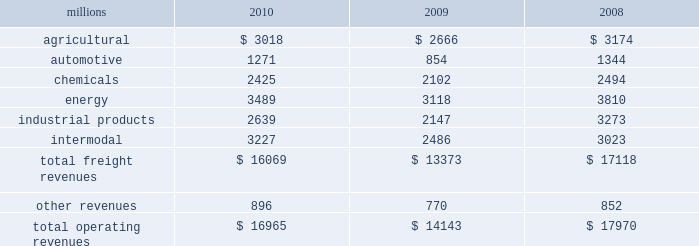Notes to the consolidated financial statements union pacific corporation and subsidiary companies for purposes of this report , unless the context otherwise requires , all references herein to the 201ccorporation 201d , 201cupc 201d , 201cwe 201d , 201cus 201d , and 201cour 201d mean union pacific corporation and its subsidiaries , including union pacific railroad company , which will be separately referred to herein as 201cuprr 201d or the 201crailroad 201d .
Nature of operations operations and segmentation 2013 we are a class i railroad that operates in the u.s .
We have 31953 route miles , linking pacific coast and gulf coast ports with the midwest and eastern u.s .
Gateways and providing several corridors to key mexican gateways .
We serve the western two-thirds of the country and maintain coordinated schedules with other rail carriers for the handling of freight to and from the atlantic coast , the pacific coast , the southeast , the southwest , canada , and mexico .
Export and import traffic is moved through gulf coast and pacific coast ports and across the mexican and canadian borders .
The railroad , along with its subsidiaries and rail affiliates , is our one reportable operating segment .
Although revenues are analyzed by commodity group , we analyze the net financial results of the railroad as one segment due to the integrated nature of our rail network .
The table provides revenue by commodity group : millions 2010 2009 2008 .
Although our revenues are principally derived from customers domiciled in the u.s. , the ultimate points of origination or destination for some products transported are outside the u.s .
Basis of presentation 2013 the consolidated financial statements are presented in accordance with accounting principles generally accepted in the u.s .
( gaap ) as codified in the financial accounting standards board ( fasb ) accounting standards codification ( asc ) .
Significant accounting policies principles of consolidation 2013 the consolidated financial statements include the accounts of union pacific corporation and all of its subsidiaries .
Investments in affiliated companies ( 20% ( 20 % ) to 50% ( 50 % ) owned ) are accounted for using the equity method of accounting .
All intercompany transactions are eliminated .
We currently have no less than majority-owned investments that require consolidation under variable interest entity requirements .
Cash and cash equivalents 2013 cash equivalents consist of investments with original maturities of three months or less .
Accounts receivable 2013 accounts receivable includes receivables reduced by an allowance for doubtful accounts .
The allowance is based upon historical losses , credit worthiness of customers , and current economic conditions .
Receivables not expected to be collected in one year and the associated allowances are classified as other assets in our consolidated statements of financial position .
Investments 2013 investments represent our investments in affiliated companies ( 20% ( 20 % ) to 50% ( 50 % ) owned ) that are accounted for under the equity method of accounting and investments in companies ( less than 20% ( 20 % ) owned ) accounted for under the cost method of accounting. .
In millions , what is the average for other revenue from 2008-2010? 
Computations: (((896 + 770) + 852) / 3)
Answer: 839.33333. 